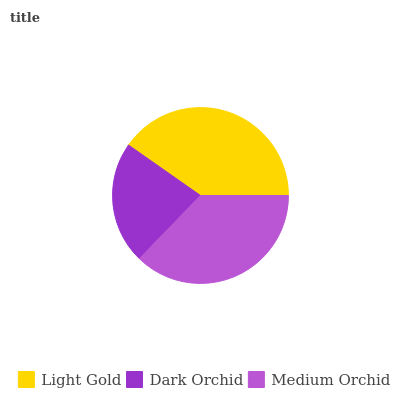Is Dark Orchid the minimum?
Answer yes or no. Yes. Is Light Gold the maximum?
Answer yes or no. Yes. Is Medium Orchid the minimum?
Answer yes or no. No. Is Medium Orchid the maximum?
Answer yes or no. No. Is Medium Orchid greater than Dark Orchid?
Answer yes or no. Yes. Is Dark Orchid less than Medium Orchid?
Answer yes or no. Yes. Is Dark Orchid greater than Medium Orchid?
Answer yes or no. No. Is Medium Orchid less than Dark Orchid?
Answer yes or no. No. Is Medium Orchid the high median?
Answer yes or no. Yes. Is Medium Orchid the low median?
Answer yes or no. Yes. Is Light Gold the high median?
Answer yes or no. No. Is Light Gold the low median?
Answer yes or no. No. 